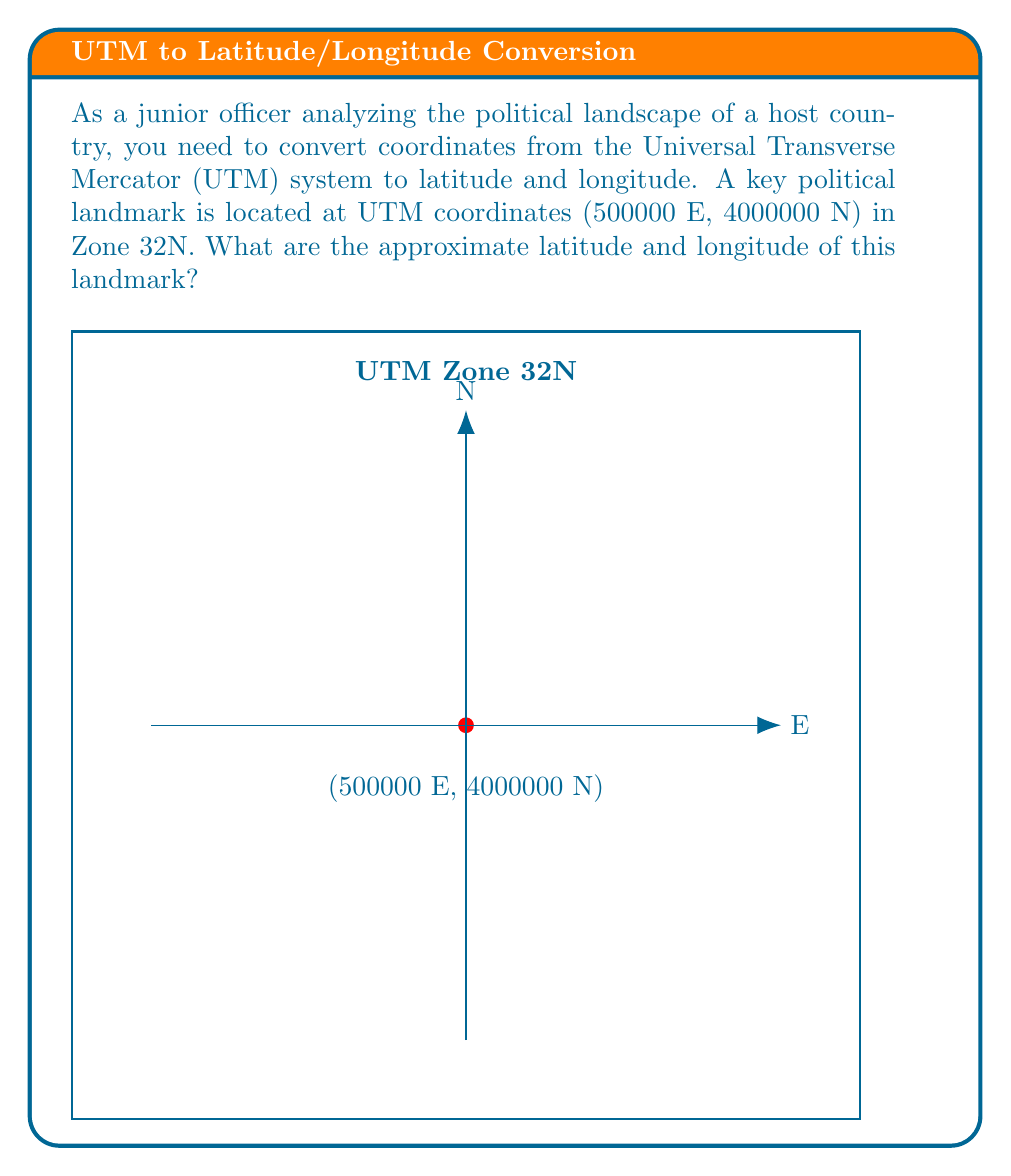Teach me how to tackle this problem. To convert from UTM coordinates to latitude and longitude, we'll follow these steps:

1) First, recognize that UTM Zone 32N is centered on the 9°E meridian.

2) The easting value of 500000 m indicates that the point is on the central meridian (9°E), as 500000 m is the false easting added to all UTM coordinates.

3) For the northing, we need to convert 4000000 m to a latitude. In the northern hemisphere, the equator is at 0 m northing. Each degree of latitude is approximately 111,320 m.

4) Calculate the approximate latitude:
   $$ \text{Latitude} \approx \frac{4000000 \text{ m}}{111320 \text{ m/degree}} \approx 35.93^\circ \text{N} $$

5) Round to the nearest minute for practical use:
   $$ 35.93^\circ \text{N} \approx 35^\circ 56' \text{N} $$

6) The longitude is simply the central meridian of Zone 32N, which is 9°E.

Therefore, the approximate coordinates are 35°56'N, 9°E.
Answer: 35°56'N, 9°E 